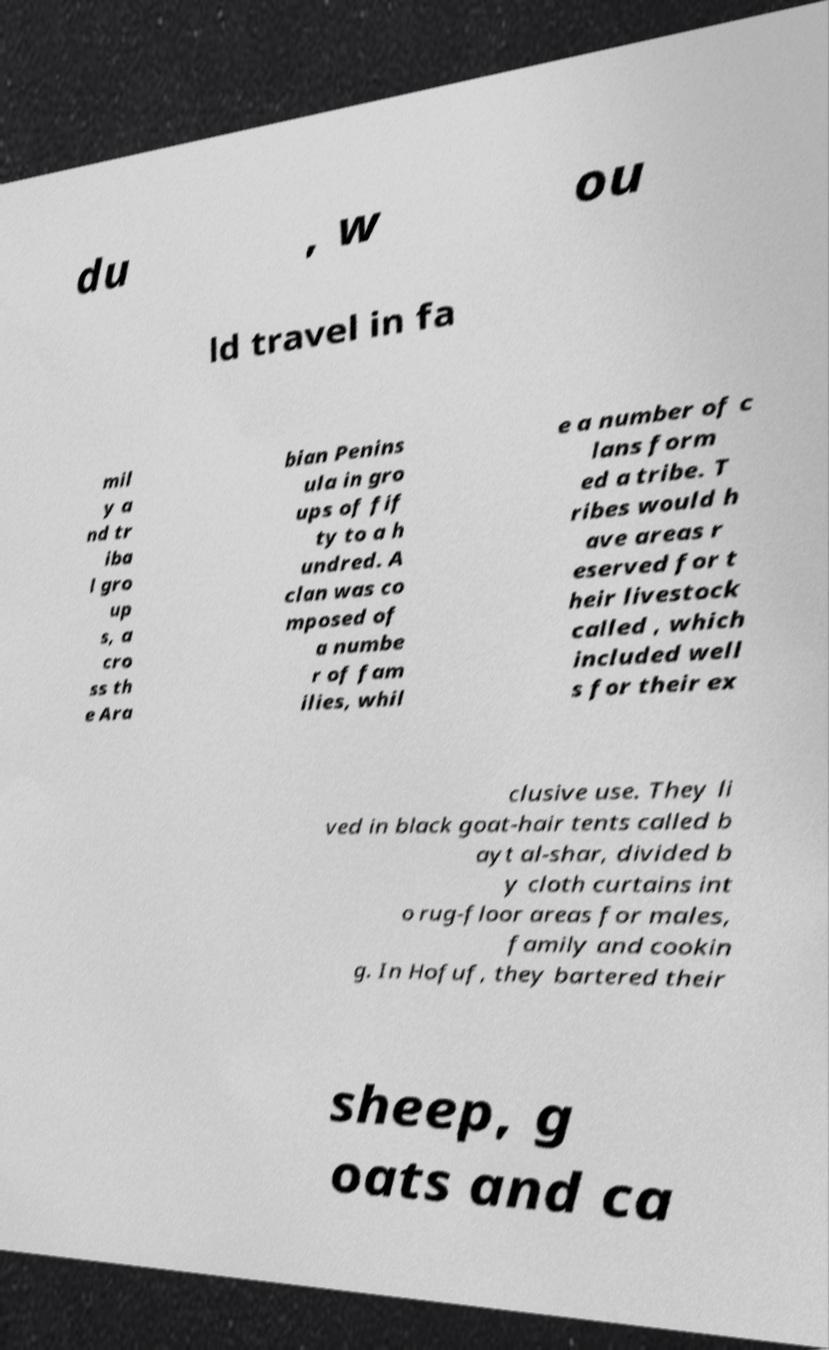For documentation purposes, I need the text within this image transcribed. Could you provide that? du , w ou ld travel in fa mil y a nd tr iba l gro up s, a cro ss th e Ara bian Penins ula in gro ups of fif ty to a h undred. A clan was co mposed of a numbe r of fam ilies, whil e a number of c lans form ed a tribe. T ribes would h ave areas r eserved for t heir livestock called , which included well s for their ex clusive use. They li ved in black goat-hair tents called b ayt al-shar, divided b y cloth curtains int o rug-floor areas for males, family and cookin g. In Hofuf, they bartered their sheep, g oats and ca 